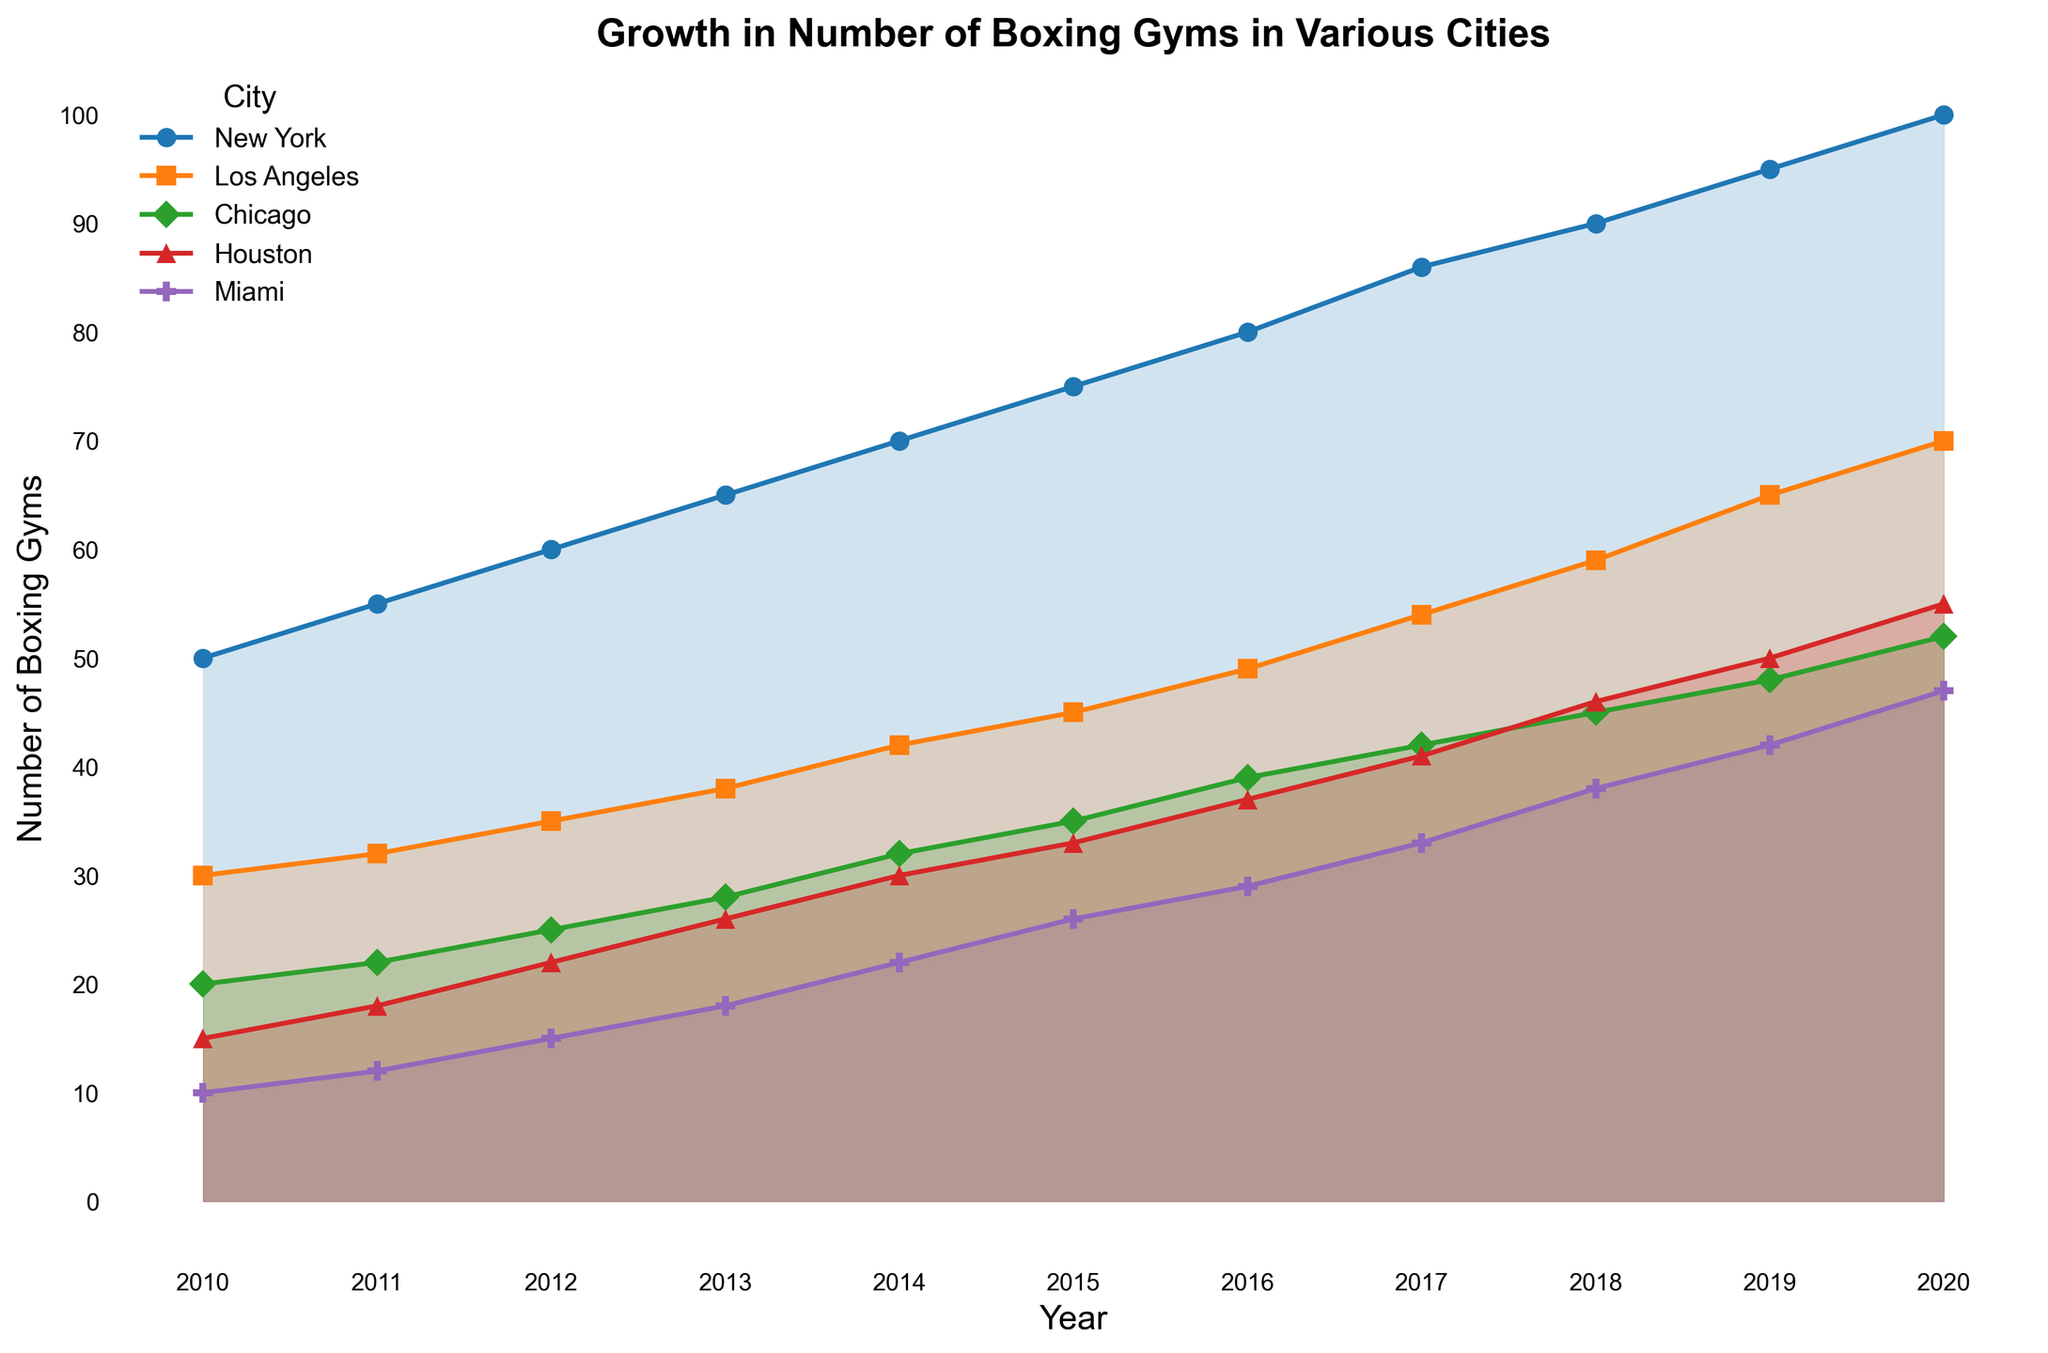What's the city with the most significant growth in the number of boxing gyms from 2010 to 2020? By comparing the values from 2010 to 2020 for each city, we see New York started with 50 gyms in 2010 and had 100 in 2020. That's a growth of 50 gyms. No other city has growth this large.
Answer: New York Which city had the most boxing gyms in 2015? By looking at the plot for 2015, New York has the highest point compared to other cities. New York had 75 gyms in 2015.
Answer: New York How does the growth trend in Miami compare to Houston over the years? By examining the line trends for Miami and Houston, both have a positive trend, but Miami's growth slope is slightly less steep compared to Houston's. They start with fewer gyms and grow at a somewhat slower pace.
Answer: Miami grows slower than Houston What's the average number of boxing gyms in Los Angeles over the years? To calculate the average, sum all the values for Los Angeles from 2010 to 2020 and divide by the number of years. Sum is 30+32+35+38+42+45+49+54+59+65+70 = 519. Dividing by 11 gives 47.18.
Answer: 47.18 In which year did Chicago have the same number of gyms as Miami? Look at the points where the lines intersect. Chicago and Miami both had the same number of gyms in 2013.
Answer: 2013 Which city's boxing gyms never crossed the 60 mark throughout all the years? By observing the plot, Chicago's line never reaches above 60 gyms.
Answer: Chicago How many more boxing gyms did New York have in 2020 compared to Los Angeles in 2020? New York had 100 gyms in 2020, while Los Angeles had 70. The difference is 100 - 70.
Answer: 30 In what year did Houston's gyms surpass 30 gyms? Check Houston's visual line for when it goes above 30. It happened in 2014.
Answer: 2014 